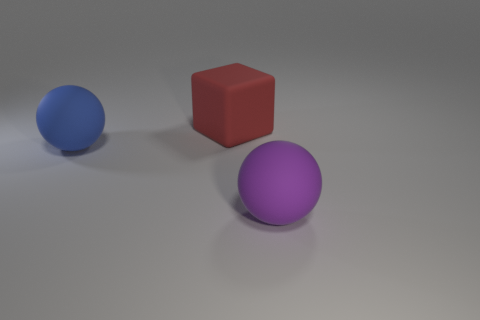Is the shape of the big thing that is left of the big red block the same as the large rubber object that is in front of the big blue rubber ball?
Make the answer very short. Yes. Is there another big ball that has the same material as the big blue sphere?
Your answer should be compact. Yes. There is a large matte object on the left side of the red matte cube that is behind the large purple sphere that is in front of the large red thing; what is its color?
Your response must be concise. Blue. There is a big matte thing in front of the big blue ball; what is its shape?
Your answer should be compact. Sphere. How many things are large balls or large matte things that are behind the big purple rubber object?
Ensure brevity in your answer.  3. Are the large cube and the blue thing made of the same material?
Offer a very short reply. Yes. Is the number of things to the right of the blue rubber sphere the same as the number of matte blocks on the left side of the big cube?
Your answer should be very brief. No. How many rubber objects are behind the purple matte object?
Your answer should be compact. 2. What number of objects are either big purple balls or blue balls?
Offer a terse response. 2. What number of blue spheres have the same size as the purple matte thing?
Offer a very short reply. 1. 